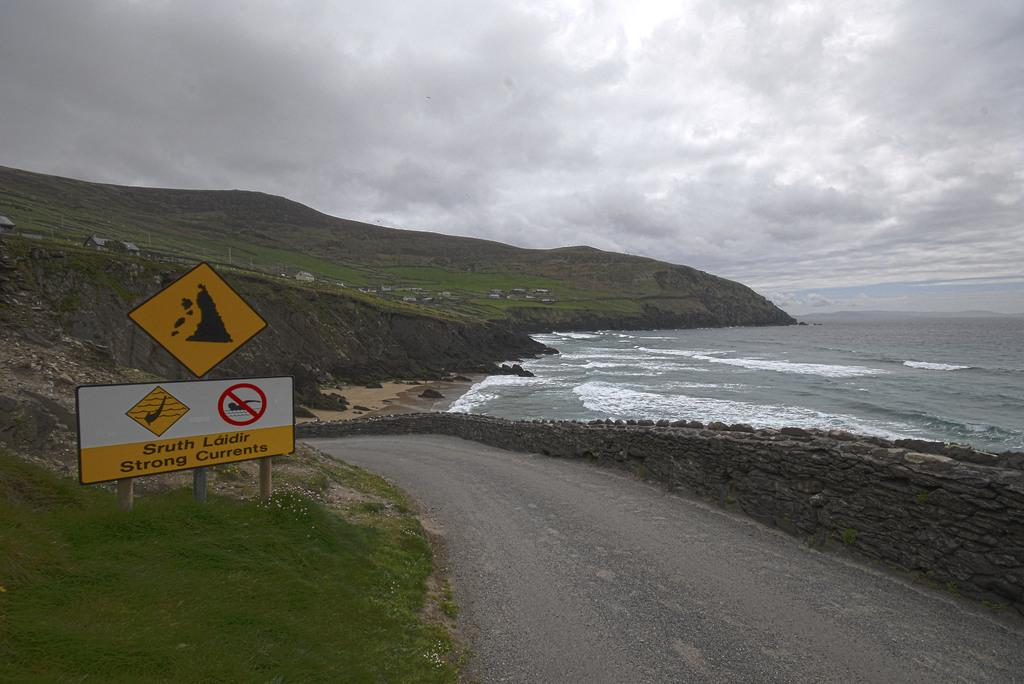<image>
Summarize the visual content of the image. Road that leads to a coast with a sign saying strong currents. 